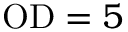<formula> <loc_0><loc_0><loc_500><loc_500>O D = 5</formula> 